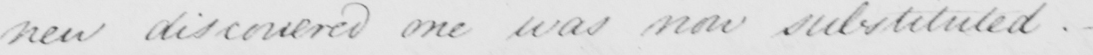Transcribe the text shown in this historical manuscript line. new discovered one was now substituted. _ 